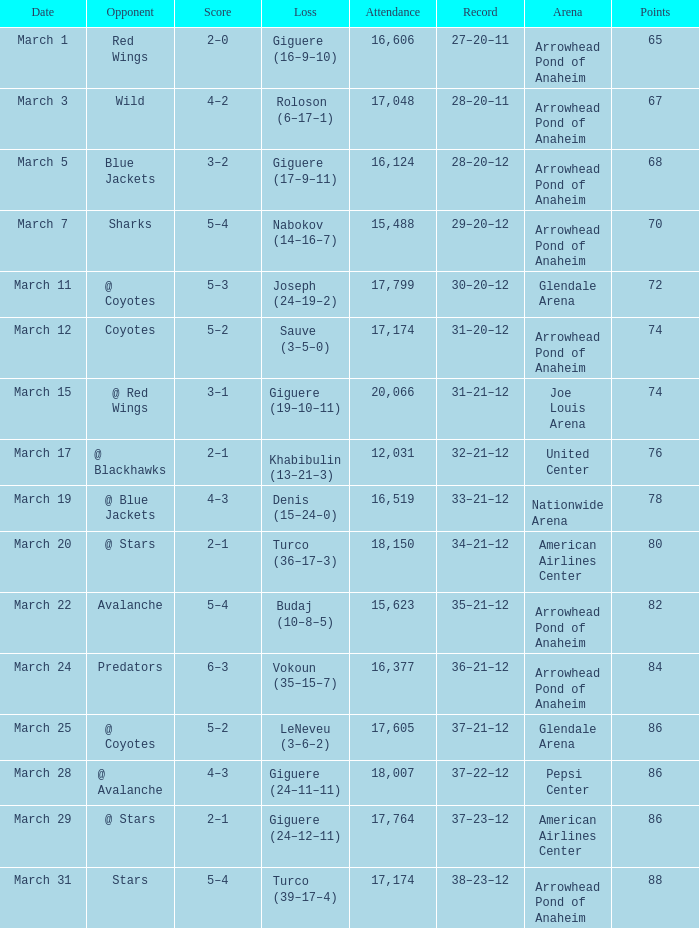What is the presence at the match with a record of 37-21-12 and under 86 points? None. 